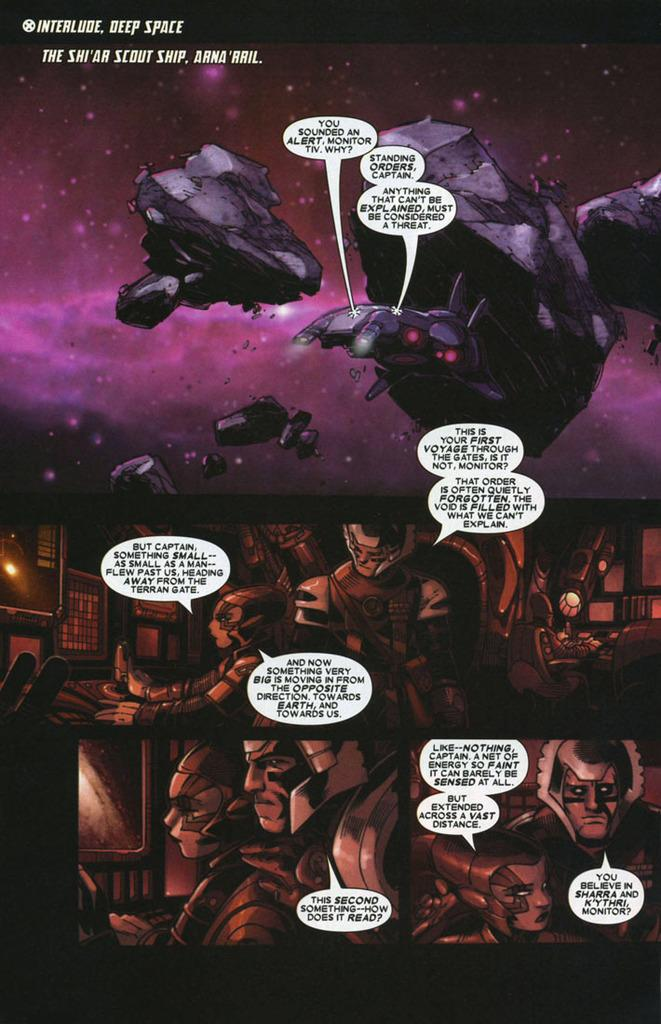What type of pictures are present in the image? There are animated pictures in the image. What is featured on the animated pictures? There is text written on the animated pictures. What type of letter is being knitted with yarn in the image? There is no letter or yarn present in the image; it only features animated pictures with text. 